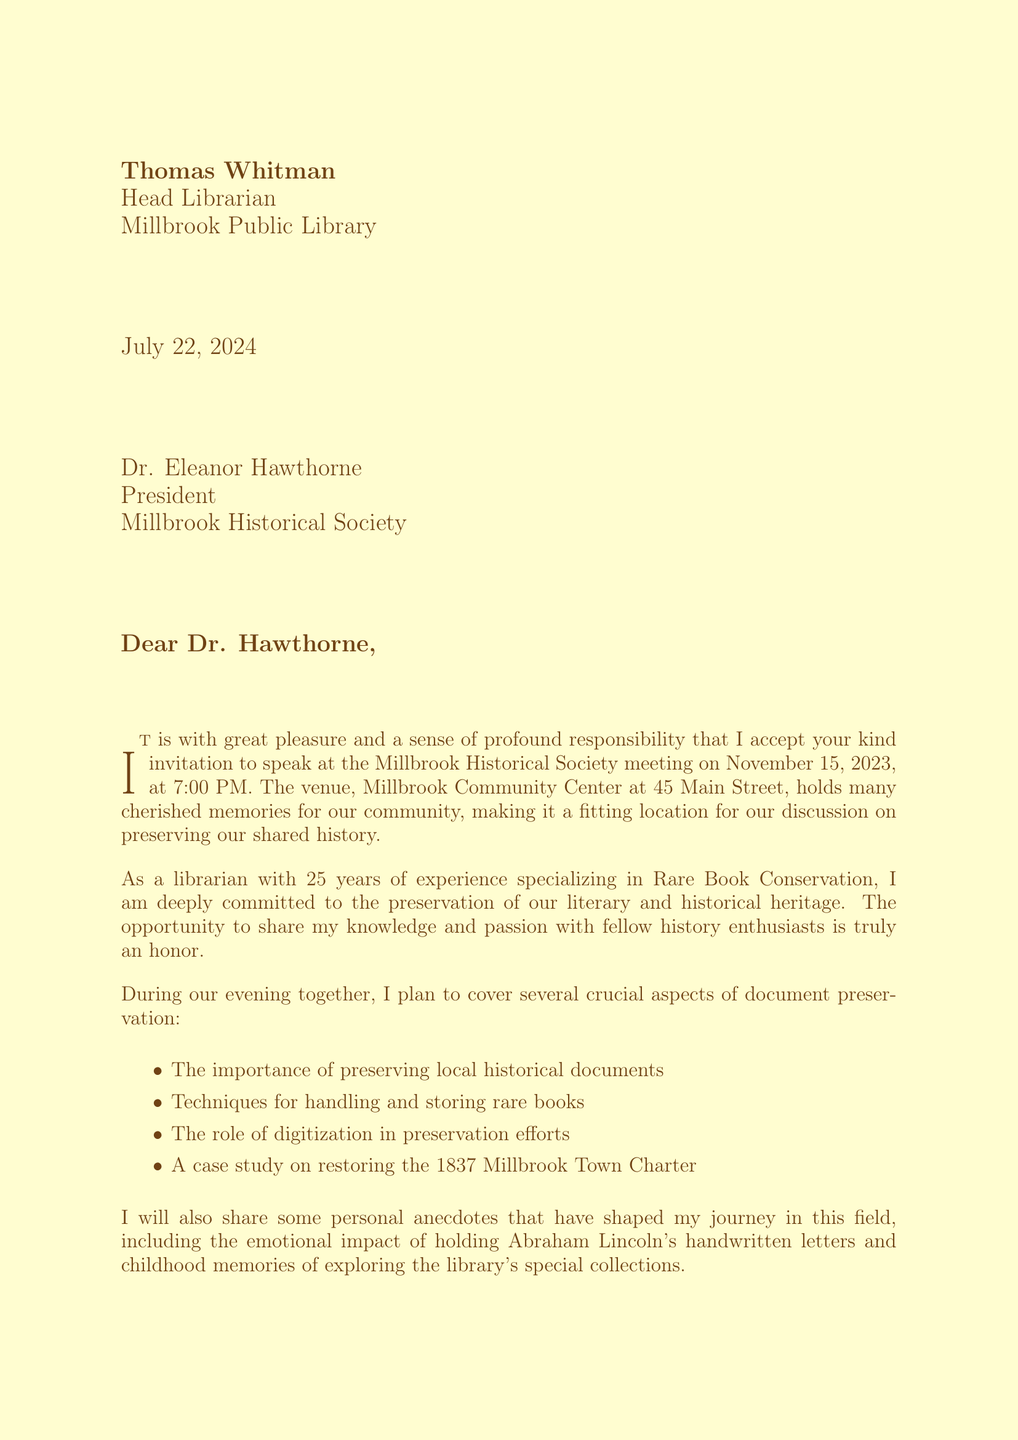What is the name of the recipient? The recipient is specifically identified as Dr. Eleanor Hawthorne in the letter.
Answer: Dr. Eleanor Hawthorne What is the date of the meeting? The meeting date is explicitly stated in the document as November 15, 2023.
Answer: November 15, 2023 Who is the speaker? The letter indicates that Thomas Whitman is the speaker at the meeting.
Answer: Thomas Whitman What is one topic to be discussed during the presentation? The letter lists several topics, one of which is "The importance of preserving local historical documents."
Answer: The importance of preserving local historical documents What personal anecdote involves a famous literary work? The speaker mentions discovering a first edition of 'To Kill a Mockingbird' in a donation box as a personal anecdote.
Answer: 'To Kill a Mockingbird' How many years of experience does the speaker have? The letter states that the speaker has 25 years of experience in the field.
Answer: 25 years What is the goal for the Millbrook Public Library mentioned in the letter? The letter indicates the future goal is to establish a dedicated rare book room at the library.
Answer: Establishing a dedicated rare book room Where is the venue located? The letter provides the address of the venue as 45 Main Street, Millbrook, NY 12545.
Answer: 45 Main Street, Millbrook, NY 12545 What type of document is this? The format of the text is consistent with a formal letter addressed to an individual regarding a public speaking engagement.
Answer: A formal letter 